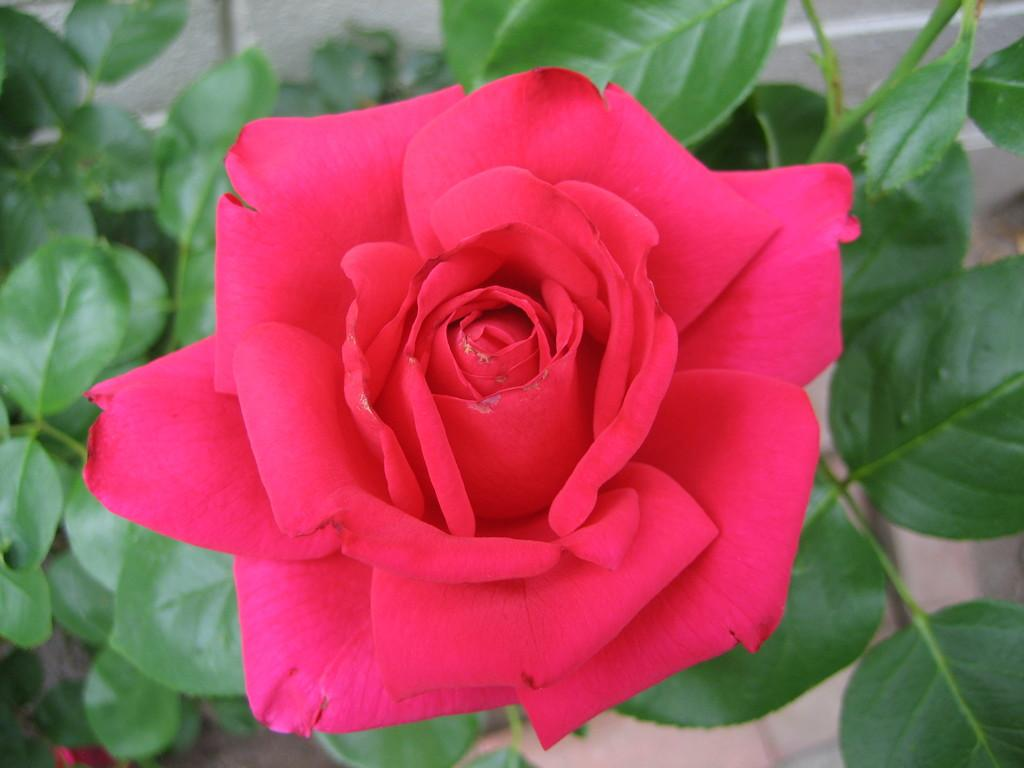What type of flower is in the image? There is a red rose in the image. What color are the leaves in the image? The leaves in the image are green. What is at the bottom of the image? There is a floor at the bottom of the image. What type of jeans is the person wearing in the image? There is no person or jeans present in the image; it only features a red rose and green leaves. 